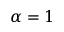Convert formula to latex. <formula><loc_0><loc_0><loc_500><loc_500>\alpha = 1</formula> 